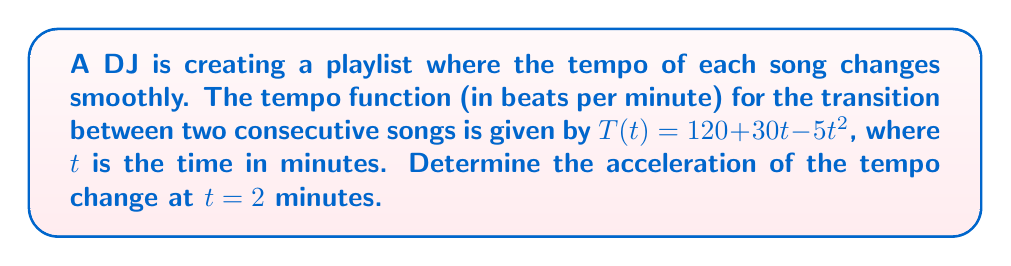Can you answer this question? To find the acceleration of the tempo change, we need to find the second derivative of the tempo function $T(t)$.

Step 1: Find the first derivative (velocity of tempo change)
The first derivative represents the rate of change of tempo:
$$T'(t) = \frac{d}{dt}(120 + 30t - 5t^2) = 30 - 10t$$

Step 2: Find the second derivative (acceleration of tempo change)
The second derivative represents the rate of change of the velocity, which is the acceleration:
$$T''(t) = \frac{d}{dt}(30 - 10t) = -10$$

Step 3: Evaluate the acceleration at $t = 2$
Since the second derivative is constant, the acceleration is the same at all times, including $t = 2$:
$$T''(2) = -10$$

The negative sign indicates that the tempo is decreasing at an accelerating rate.
Answer: $-10$ beats per minute per minute squared 